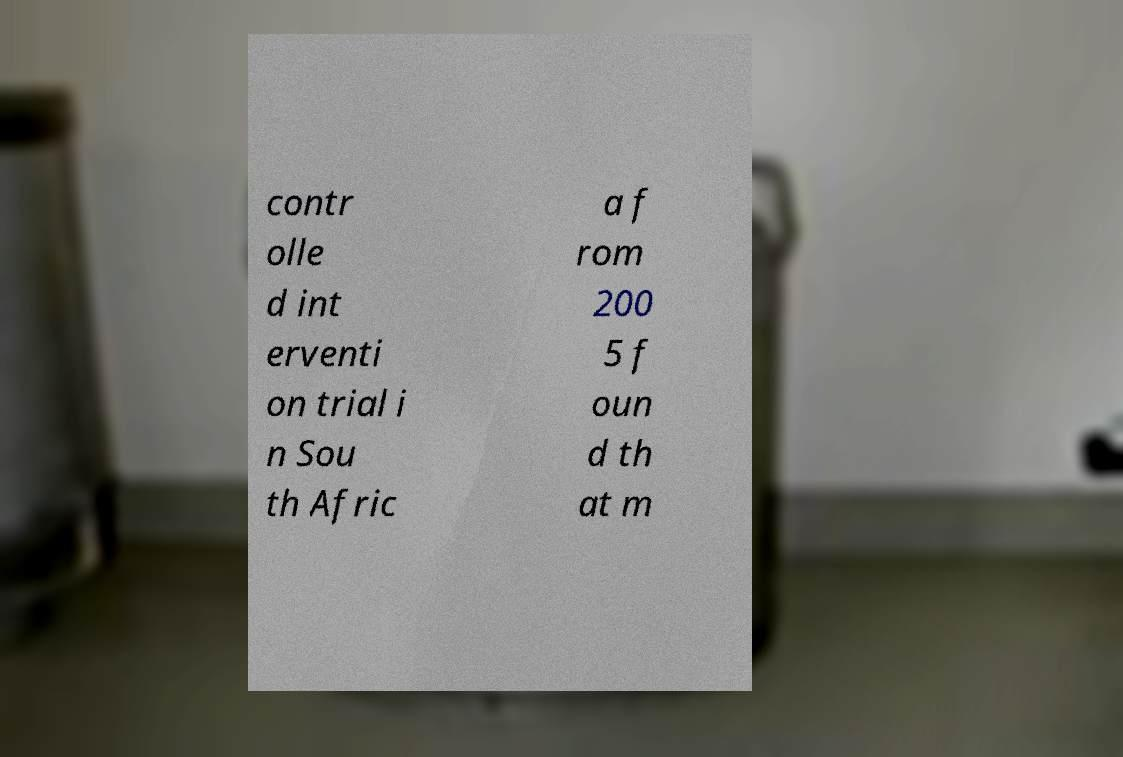I need the written content from this picture converted into text. Can you do that? contr olle d int erventi on trial i n Sou th Afric a f rom 200 5 f oun d th at m 